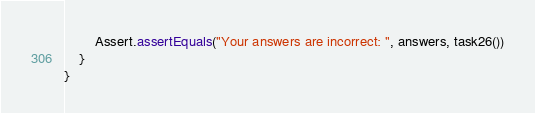Convert code to text. <code><loc_0><loc_0><loc_500><loc_500><_Kotlin_>        Assert.assertEquals("Your answers are incorrect: ", answers, task26())
    }
}</code> 